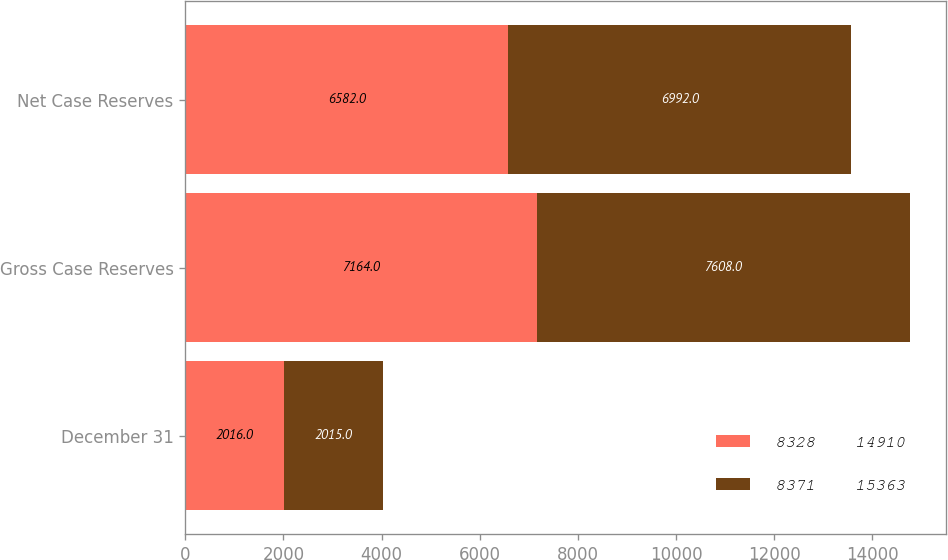Convert chart to OTSL. <chart><loc_0><loc_0><loc_500><loc_500><stacked_bar_chart><ecel><fcel>December 31<fcel>Gross Case Reserves<fcel>Net Case Reserves<nl><fcel>8328    14910<fcel>2016<fcel>7164<fcel>6582<nl><fcel>8371    15363<fcel>2015<fcel>7608<fcel>6992<nl></chart> 